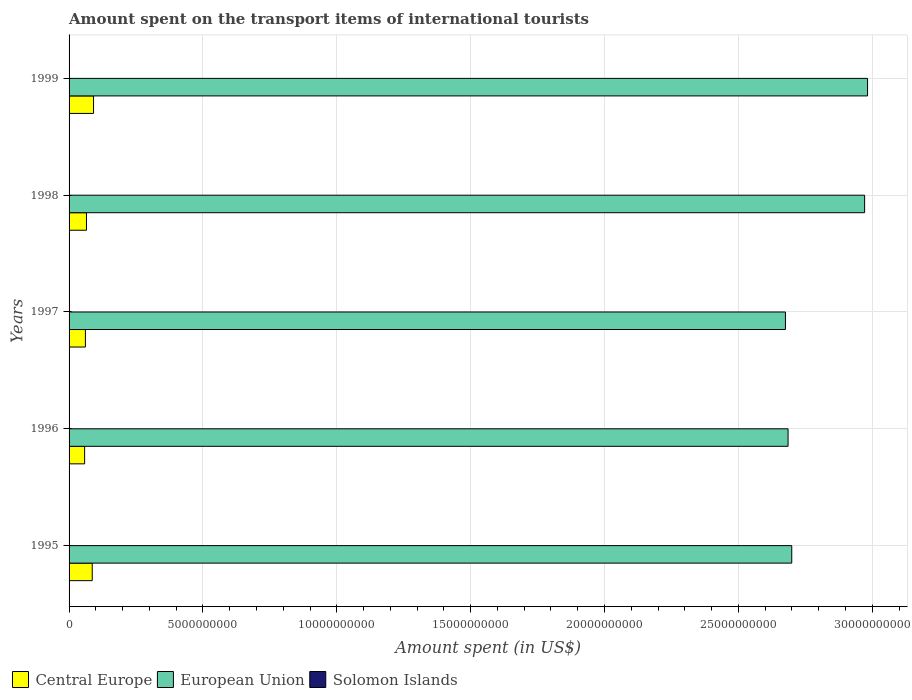How many different coloured bars are there?
Your response must be concise. 3. How many groups of bars are there?
Provide a short and direct response. 5. Are the number of bars per tick equal to the number of legend labels?
Your answer should be very brief. Yes. How many bars are there on the 2nd tick from the top?
Offer a terse response. 3. How many bars are there on the 4th tick from the bottom?
Your response must be concise. 3. What is the label of the 4th group of bars from the top?
Your answer should be compact. 1996. In how many cases, is the number of bars for a given year not equal to the number of legend labels?
Keep it short and to the point. 0. What is the amount spent on the transport items of international tourists in Central Europe in 1996?
Provide a succinct answer. 5.81e+08. Across all years, what is the maximum amount spent on the transport items of international tourists in Central Europe?
Your answer should be very brief. 9.14e+08. Across all years, what is the minimum amount spent on the transport items of international tourists in European Union?
Provide a succinct answer. 2.68e+1. In which year was the amount spent on the transport items of international tourists in European Union minimum?
Ensure brevity in your answer.  1997. What is the total amount spent on the transport items of international tourists in Central Europe in the graph?
Give a very brief answer. 3.62e+09. What is the difference between the amount spent on the transport items of international tourists in Central Europe in 1995 and that in 1998?
Give a very brief answer. 2.16e+08. What is the difference between the amount spent on the transport items of international tourists in Solomon Islands in 1997 and the amount spent on the transport items of international tourists in Central Europe in 1999?
Give a very brief answer. -9.09e+08. What is the average amount spent on the transport items of international tourists in Solomon Islands per year?
Your answer should be very brief. 4.32e+06. In the year 1998, what is the difference between the amount spent on the transport items of international tourists in European Union and amount spent on the transport items of international tourists in Central Europe?
Ensure brevity in your answer.  2.91e+1. What is the ratio of the amount spent on the transport items of international tourists in Central Europe in 1996 to that in 1998?
Give a very brief answer. 0.89. Is the difference between the amount spent on the transport items of international tourists in European Union in 1995 and 1998 greater than the difference between the amount spent on the transport items of international tourists in Central Europe in 1995 and 1998?
Your answer should be very brief. No. What is the difference between the highest and the second highest amount spent on the transport items of international tourists in European Union?
Make the answer very short. 1.11e+08. What is the difference between the highest and the lowest amount spent on the transport items of international tourists in Central Europe?
Offer a very short reply. 3.33e+08. What does the 1st bar from the top in 1999 represents?
Your answer should be very brief. Solomon Islands. Is it the case that in every year, the sum of the amount spent on the transport items of international tourists in Central Europe and amount spent on the transport items of international tourists in Solomon Islands is greater than the amount spent on the transport items of international tourists in European Union?
Make the answer very short. No. How many bars are there?
Your response must be concise. 15. Does the graph contain any zero values?
Your answer should be very brief. No. How many legend labels are there?
Ensure brevity in your answer.  3. How are the legend labels stacked?
Offer a terse response. Horizontal. What is the title of the graph?
Provide a short and direct response. Amount spent on the transport items of international tourists. Does "Netherlands" appear as one of the legend labels in the graph?
Offer a terse response. No. What is the label or title of the X-axis?
Your answer should be compact. Amount spent (in US$). What is the label or title of the Y-axis?
Keep it short and to the point. Years. What is the Amount spent (in US$) of Central Europe in 1995?
Provide a short and direct response. 8.65e+08. What is the Amount spent (in US$) in European Union in 1995?
Make the answer very short. 2.70e+1. What is the Amount spent (in US$) in Solomon Islands in 1995?
Give a very brief answer. 3.90e+06. What is the Amount spent (in US$) in Central Europe in 1996?
Make the answer very short. 5.81e+08. What is the Amount spent (in US$) of European Union in 1996?
Your answer should be very brief. 2.69e+1. What is the Amount spent (in US$) in Solomon Islands in 1996?
Provide a short and direct response. 3.30e+06. What is the Amount spent (in US$) in Central Europe in 1997?
Offer a terse response. 6.10e+08. What is the Amount spent (in US$) of European Union in 1997?
Provide a short and direct response. 2.68e+1. What is the Amount spent (in US$) in Solomon Islands in 1997?
Keep it short and to the point. 5.80e+06. What is the Amount spent (in US$) of Central Europe in 1998?
Your response must be concise. 6.50e+08. What is the Amount spent (in US$) in European Union in 1998?
Your response must be concise. 2.97e+1. What is the Amount spent (in US$) in Solomon Islands in 1998?
Provide a short and direct response. 4.40e+06. What is the Amount spent (in US$) of Central Europe in 1999?
Give a very brief answer. 9.14e+08. What is the Amount spent (in US$) of European Union in 1999?
Your response must be concise. 2.98e+1. What is the Amount spent (in US$) in Solomon Islands in 1999?
Provide a short and direct response. 4.20e+06. Across all years, what is the maximum Amount spent (in US$) in Central Europe?
Ensure brevity in your answer.  9.14e+08. Across all years, what is the maximum Amount spent (in US$) of European Union?
Provide a succinct answer. 2.98e+1. Across all years, what is the maximum Amount spent (in US$) in Solomon Islands?
Make the answer very short. 5.80e+06. Across all years, what is the minimum Amount spent (in US$) of Central Europe?
Offer a very short reply. 5.81e+08. Across all years, what is the minimum Amount spent (in US$) of European Union?
Keep it short and to the point. 2.68e+1. Across all years, what is the minimum Amount spent (in US$) of Solomon Islands?
Give a very brief answer. 3.30e+06. What is the total Amount spent (in US$) in Central Europe in the graph?
Keep it short and to the point. 3.62e+09. What is the total Amount spent (in US$) of European Union in the graph?
Keep it short and to the point. 1.40e+11. What is the total Amount spent (in US$) of Solomon Islands in the graph?
Offer a very short reply. 2.16e+07. What is the difference between the Amount spent (in US$) in Central Europe in 1995 and that in 1996?
Offer a very short reply. 2.85e+08. What is the difference between the Amount spent (in US$) of European Union in 1995 and that in 1996?
Your response must be concise. 1.37e+08. What is the difference between the Amount spent (in US$) of Solomon Islands in 1995 and that in 1996?
Provide a short and direct response. 6.00e+05. What is the difference between the Amount spent (in US$) in Central Europe in 1995 and that in 1997?
Offer a very short reply. 2.55e+08. What is the difference between the Amount spent (in US$) in European Union in 1995 and that in 1997?
Give a very brief answer. 2.35e+08. What is the difference between the Amount spent (in US$) of Solomon Islands in 1995 and that in 1997?
Provide a succinct answer. -1.90e+06. What is the difference between the Amount spent (in US$) in Central Europe in 1995 and that in 1998?
Ensure brevity in your answer.  2.16e+08. What is the difference between the Amount spent (in US$) in European Union in 1995 and that in 1998?
Keep it short and to the point. -2.72e+09. What is the difference between the Amount spent (in US$) of Solomon Islands in 1995 and that in 1998?
Your answer should be very brief. -5.00e+05. What is the difference between the Amount spent (in US$) in Central Europe in 1995 and that in 1999?
Your answer should be compact. -4.90e+07. What is the difference between the Amount spent (in US$) in European Union in 1995 and that in 1999?
Offer a terse response. -2.83e+09. What is the difference between the Amount spent (in US$) of Central Europe in 1996 and that in 1997?
Your answer should be compact. -2.91e+07. What is the difference between the Amount spent (in US$) of European Union in 1996 and that in 1997?
Give a very brief answer. 9.81e+07. What is the difference between the Amount spent (in US$) in Solomon Islands in 1996 and that in 1997?
Provide a succinct answer. -2.50e+06. What is the difference between the Amount spent (in US$) of Central Europe in 1996 and that in 1998?
Give a very brief answer. -6.88e+07. What is the difference between the Amount spent (in US$) of European Union in 1996 and that in 1998?
Offer a very short reply. -2.86e+09. What is the difference between the Amount spent (in US$) in Solomon Islands in 1996 and that in 1998?
Make the answer very short. -1.10e+06. What is the difference between the Amount spent (in US$) of Central Europe in 1996 and that in 1999?
Your answer should be very brief. -3.33e+08. What is the difference between the Amount spent (in US$) in European Union in 1996 and that in 1999?
Provide a short and direct response. -2.97e+09. What is the difference between the Amount spent (in US$) of Solomon Islands in 1996 and that in 1999?
Offer a terse response. -9.00e+05. What is the difference between the Amount spent (in US$) in Central Europe in 1997 and that in 1998?
Your answer should be very brief. -3.97e+07. What is the difference between the Amount spent (in US$) in European Union in 1997 and that in 1998?
Offer a terse response. -2.96e+09. What is the difference between the Amount spent (in US$) of Solomon Islands in 1997 and that in 1998?
Your answer should be compact. 1.40e+06. What is the difference between the Amount spent (in US$) of Central Europe in 1997 and that in 1999?
Your response must be concise. -3.04e+08. What is the difference between the Amount spent (in US$) in European Union in 1997 and that in 1999?
Ensure brevity in your answer.  -3.07e+09. What is the difference between the Amount spent (in US$) in Solomon Islands in 1997 and that in 1999?
Provide a succinct answer. 1.60e+06. What is the difference between the Amount spent (in US$) in Central Europe in 1998 and that in 1999?
Provide a short and direct response. -2.65e+08. What is the difference between the Amount spent (in US$) in European Union in 1998 and that in 1999?
Your response must be concise. -1.11e+08. What is the difference between the Amount spent (in US$) in Solomon Islands in 1998 and that in 1999?
Provide a succinct answer. 2.00e+05. What is the difference between the Amount spent (in US$) of Central Europe in 1995 and the Amount spent (in US$) of European Union in 1996?
Your answer should be very brief. -2.60e+1. What is the difference between the Amount spent (in US$) in Central Europe in 1995 and the Amount spent (in US$) in Solomon Islands in 1996?
Make the answer very short. 8.62e+08. What is the difference between the Amount spent (in US$) of European Union in 1995 and the Amount spent (in US$) of Solomon Islands in 1996?
Provide a succinct answer. 2.70e+1. What is the difference between the Amount spent (in US$) of Central Europe in 1995 and the Amount spent (in US$) of European Union in 1997?
Provide a short and direct response. -2.59e+1. What is the difference between the Amount spent (in US$) of Central Europe in 1995 and the Amount spent (in US$) of Solomon Islands in 1997?
Your response must be concise. 8.60e+08. What is the difference between the Amount spent (in US$) in European Union in 1995 and the Amount spent (in US$) in Solomon Islands in 1997?
Make the answer very short. 2.70e+1. What is the difference between the Amount spent (in US$) of Central Europe in 1995 and the Amount spent (in US$) of European Union in 1998?
Give a very brief answer. -2.88e+1. What is the difference between the Amount spent (in US$) in Central Europe in 1995 and the Amount spent (in US$) in Solomon Islands in 1998?
Give a very brief answer. 8.61e+08. What is the difference between the Amount spent (in US$) in European Union in 1995 and the Amount spent (in US$) in Solomon Islands in 1998?
Provide a succinct answer. 2.70e+1. What is the difference between the Amount spent (in US$) of Central Europe in 1995 and the Amount spent (in US$) of European Union in 1999?
Keep it short and to the point. -2.90e+1. What is the difference between the Amount spent (in US$) of Central Europe in 1995 and the Amount spent (in US$) of Solomon Islands in 1999?
Provide a short and direct response. 8.61e+08. What is the difference between the Amount spent (in US$) of European Union in 1995 and the Amount spent (in US$) of Solomon Islands in 1999?
Offer a terse response. 2.70e+1. What is the difference between the Amount spent (in US$) in Central Europe in 1996 and the Amount spent (in US$) in European Union in 1997?
Ensure brevity in your answer.  -2.62e+1. What is the difference between the Amount spent (in US$) in Central Europe in 1996 and the Amount spent (in US$) in Solomon Islands in 1997?
Provide a short and direct response. 5.75e+08. What is the difference between the Amount spent (in US$) in European Union in 1996 and the Amount spent (in US$) in Solomon Islands in 1997?
Give a very brief answer. 2.69e+1. What is the difference between the Amount spent (in US$) in Central Europe in 1996 and the Amount spent (in US$) in European Union in 1998?
Keep it short and to the point. -2.91e+1. What is the difference between the Amount spent (in US$) in Central Europe in 1996 and the Amount spent (in US$) in Solomon Islands in 1998?
Provide a short and direct response. 5.77e+08. What is the difference between the Amount spent (in US$) of European Union in 1996 and the Amount spent (in US$) of Solomon Islands in 1998?
Give a very brief answer. 2.69e+1. What is the difference between the Amount spent (in US$) in Central Europe in 1996 and the Amount spent (in US$) in European Union in 1999?
Offer a terse response. -2.92e+1. What is the difference between the Amount spent (in US$) of Central Europe in 1996 and the Amount spent (in US$) of Solomon Islands in 1999?
Offer a very short reply. 5.77e+08. What is the difference between the Amount spent (in US$) of European Union in 1996 and the Amount spent (in US$) of Solomon Islands in 1999?
Your response must be concise. 2.69e+1. What is the difference between the Amount spent (in US$) of Central Europe in 1997 and the Amount spent (in US$) of European Union in 1998?
Your answer should be compact. -2.91e+1. What is the difference between the Amount spent (in US$) in Central Europe in 1997 and the Amount spent (in US$) in Solomon Islands in 1998?
Offer a very short reply. 6.06e+08. What is the difference between the Amount spent (in US$) in European Union in 1997 and the Amount spent (in US$) in Solomon Islands in 1998?
Provide a short and direct response. 2.68e+1. What is the difference between the Amount spent (in US$) in Central Europe in 1997 and the Amount spent (in US$) in European Union in 1999?
Provide a succinct answer. -2.92e+1. What is the difference between the Amount spent (in US$) in Central Europe in 1997 and the Amount spent (in US$) in Solomon Islands in 1999?
Offer a terse response. 6.06e+08. What is the difference between the Amount spent (in US$) in European Union in 1997 and the Amount spent (in US$) in Solomon Islands in 1999?
Keep it short and to the point. 2.68e+1. What is the difference between the Amount spent (in US$) in Central Europe in 1998 and the Amount spent (in US$) in European Union in 1999?
Your answer should be very brief. -2.92e+1. What is the difference between the Amount spent (in US$) of Central Europe in 1998 and the Amount spent (in US$) of Solomon Islands in 1999?
Ensure brevity in your answer.  6.46e+08. What is the difference between the Amount spent (in US$) in European Union in 1998 and the Amount spent (in US$) in Solomon Islands in 1999?
Ensure brevity in your answer.  2.97e+1. What is the average Amount spent (in US$) of Central Europe per year?
Your answer should be compact. 7.24e+08. What is the average Amount spent (in US$) of European Union per year?
Keep it short and to the point. 2.80e+1. What is the average Amount spent (in US$) of Solomon Islands per year?
Offer a very short reply. 4.32e+06. In the year 1995, what is the difference between the Amount spent (in US$) of Central Europe and Amount spent (in US$) of European Union?
Your answer should be very brief. -2.61e+1. In the year 1995, what is the difference between the Amount spent (in US$) in Central Europe and Amount spent (in US$) in Solomon Islands?
Provide a succinct answer. 8.62e+08. In the year 1995, what is the difference between the Amount spent (in US$) of European Union and Amount spent (in US$) of Solomon Islands?
Give a very brief answer. 2.70e+1. In the year 1996, what is the difference between the Amount spent (in US$) in Central Europe and Amount spent (in US$) in European Union?
Give a very brief answer. -2.63e+1. In the year 1996, what is the difference between the Amount spent (in US$) of Central Europe and Amount spent (in US$) of Solomon Islands?
Offer a terse response. 5.78e+08. In the year 1996, what is the difference between the Amount spent (in US$) in European Union and Amount spent (in US$) in Solomon Islands?
Provide a succinct answer. 2.69e+1. In the year 1997, what is the difference between the Amount spent (in US$) in Central Europe and Amount spent (in US$) in European Union?
Provide a succinct answer. -2.61e+1. In the year 1997, what is the difference between the Amount spent (in US$) of Central Europe and Amount spent (in US$) of Solomon Islands?
Your response must be concise. 6.04e+08. In the year 1997, what is the difference between the Amount spent (in US$) in European Union and Amount spent (in US$) in Solomon Islands?
Your answer should be very brief. 2.68e+1. In the year 1998, what is the difference between the Amount spent (in US$) of Central Europe and Amount spent (in US$) of European Union?
Give a very brief answer. -2.91e+1. In the year 1998, what is the difference between the Amount spent (in US$) of Central Europe and Amount spent (in US$) of Solomon Islands?
Ensure brevity in your answer.  6.45e+08. In the year 1998, what is the difference between the Amount spent (in US$) in European Union and Amount spent (in US$) in Solomon Islands?
Your answer should be compact. 2.97e+1. In the year 1999, what is the difference between the Amount spent (in US$) of Central Europe and Amount spent (in US$) of European Union?
Your response must be concise. -2.89e+1. In the year 1999, what is the difference between the Amount spent (in US$) of Central Europe and Amount spent (in US$) of Solomon Islands?
Make the answer very short. 9.10e+08. In the year 1999, what is the difference between the Amount spent (in US$) in European Union and Amount spent (in US$) in Solomon Islands?
Give a very brief answer. 2.98e+1. What is the ratio of the Amount spent (in US$) in Central Europe in 1995 to that in 1996?
Ensure brevity in your answer.  1.49. What is the ratio of the Amount spent (in US$) of Solomon Islands in 1995 to that in 1996?
Make the answer very short. 1.18. What is the ratio of the Amount spent (in US$) of Central Europe in 1995 to that in 1997?
Ensure brevity in your answer.  1.42. What is the ratio of the Amount spent (in US$) in European Union in 1995 to that in 1997?
Make the answer very short. 1.01. What is the ratio of the Amount spent (in US$) in Solomon Islands in 1995 to that in 1997?
Your answer should be compact. 0.67. What is the ratio of the Amount spent (in US$) in Central Europe in 1995 to that in 1998?
Ensure brevity in your answer.  1.33. What is the ratio of the Amount spent (in US$) of European Union in 1995 to that in 1998?
Keep it short and to the point. 0.91. What is the ratio of the Amount spent (in US$) in Solomon Islands in 1995 to that in 1998?
Offer a very short reply. 0.89. What is the ratio of the Amount spent (in US$) of Central Europe in 1995 to that in 1999?
Give a very brief answer. 0.95. What is the ratio of the Amount spent (in US$) in European Union in 1995 to that in 1999?
Make the answer very short. 0.91. What is the ratio of the Amount spent (in US$) in Solomon Islands in 1995 to that in 1999?
Give a very brief answer. 0.93. What is the ratio of the Amount spent (in US$) of Central Europe in 1996 to that in 1997?
Provide a succinct answer. 0.95. What is the ratio of the Amount spent (in US$) in European Union in 1996 to that in 1997?
Provide a succinct answer. 1. What is the ratio of the Amount spent (in US$) of Solomon Islands in 1996 to that in 1997?
Ensure brevity in your answer.  0.57. What is the ratio of the Amount spent (in US$) in Central Europe in 1996 to that in 1998?
Provide a succinct answer. 0.89. What is the ratio of the Amount spent (in US$) in European Union in 1996 to that in 1998?
Your response must be concise. 0.9. What is the ratio of the Amount spent (in US$) in Solomon Islands in 1996 to that in 1998?
Your answer should be very brief. 0.75. What is the ratio of the Amount spent (in US$) in Central Europe in 1996 to that in 1999?
Ensure brevity in your answer.  0.64. What is the ratio of the Amount spent (in US$) of European Union in 1996 to that in 1999?
Offer a very short reply. 0.9. What is the ratio of the Amount spent (in US$) of Solomon Islands in 1996 to that in 1999?
Ensure brevity in your answer.  0.79. What is the ratio of the Amount spent (in US$) of Central Europe in 1997 to that in 1998?
Your answer should be very brief. 0.94. What is the ratio of the Amount spent (in US$) of European Union in 1997 to that in 1998?
Ensure brevity in your answer.  0.9. What is the ratio of the Amount spent (in US$) of Solomon Islands in 1997 to that in 1998?
Give a very brief answer. 1.32. What is the ratio of the Amount spent (in US$) of Central Europe in 1997 to that in 1999?
Offer a very short reply. 0.67. What is the ratio of the Amount spent (in US$) of European Union in 1997 to that in 1999?
Your answer should be compact. 0.9. What is the ratio of the Amount spent (in US$) in Solomon Islands in 1997 to that in 1999?
Your answer should be compact. 1.38. What is the ratio of the Amount spent (in US$) of Central Europe in 1998 to that in 1999?
Make the answer very short. 0.71. What is the ratio of the Amount spent (in US$) of European Union in 1998 to that in 1999?
Offer a terse response. 1. What is the ratio of the Amount spent (in US$) of Solomon Islands in 1998 to that in 1999?
Offer a very short reply. 1.05. What is the difference between the highest and the second highest Amount spent (in US$) in Central Europe?
Your answer should be compact. 4.90e+07. What is the difference between the highest and the second highest Amount spent (in US$) in European Union?
Your response must be concise. 1.11e+08. What is the difference between the highest and the second highest Amount spent (in US$) of Solomon Islands?
Your answer should be compact. 1.40e+06. What is the difference between the highest and the lowest Amount spent (in US$) in Central Europe?
Keep it short and to the point. 3.33e+08. What is the difference between the highest and the lowest Amount spent (in US$) of European Union?
Provide a succinct answer. 3.07e+09. What is the difference between the highest and the lowest Amount spent (in US$) of Solomon Islands?
Make the answer very short. 2.50e+06. 